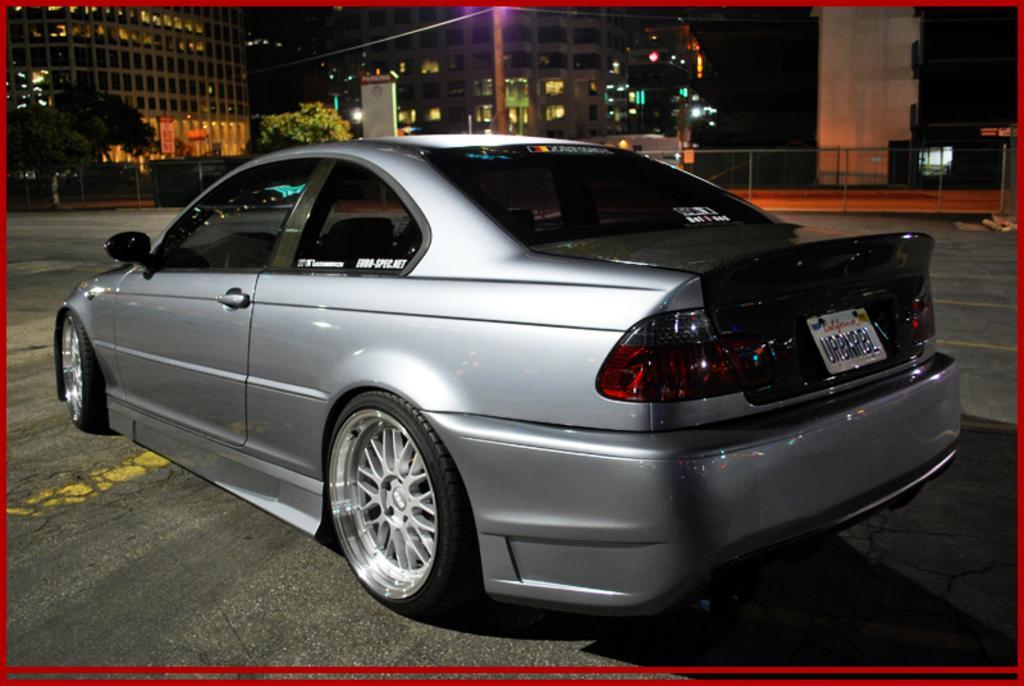Describe this image in one or two sentences. In this image, we can see a car is parked on the road. Background there are few buildings, trees, poles, lights. The border of the image, we can see red color. 